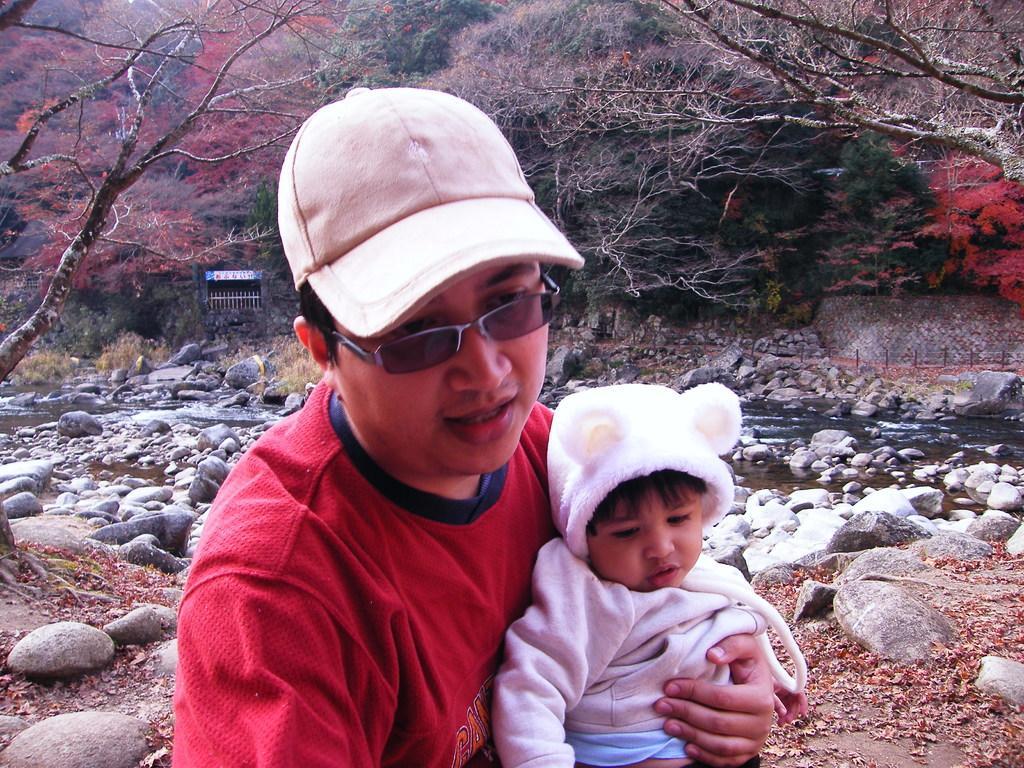Please provide a concise description of this image. This is the man holding a baby and sitting. He wore a cap, goggles and red T-shirt. These are the rocks. I can see the water flowing. This looks like a wall. These are the trees. I think this is a room with a gate. 